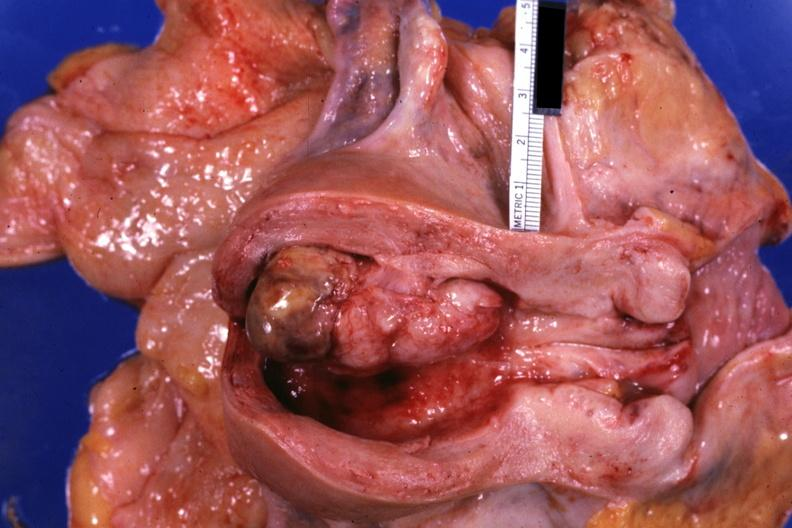does syndactyly show opened uterus with polypoid lesion?
Answer the question using a single word or phrase. No 